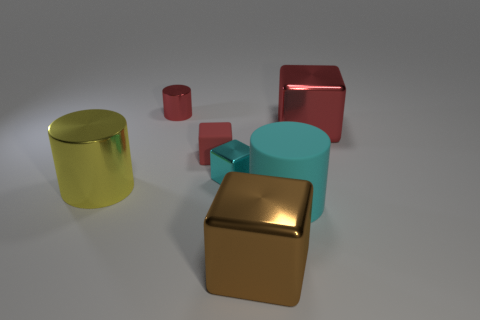Is the number of small green metallic cylinders less than the number of large cylinders?
Ensure brevity in your answer.  Yes. The small matte object that is the same shape as the cyan shiny thing is what color?
Give a very brief answer. Red. Are there any other things that have the same shape as the large rubber object?
Provide a short and direct response. Yes. Is the number of big blocks greater than the number of cyan cylinders?
Offer a terse response. Yes. How many other objects are there of the same material as the large cyan object?
Your answer should be very brief. 1. What is the shape of the cyan thing that is to the right of the big metal cube on the left side of the large block to the right of the cyan rubber object?
Provide a short and direct response. Cylinder. Is the number of yellow objects right of the red shiny block less than the number of red metal things left of the tiny matte object?
Provide a succinct answer. Yes. Are there any matte things of the same color as the tiny metal cube?
Keep it short and to the point. Yes. Is the yellow object made of the same material as the big cylinder on the right side of the red cylinder?
Keep it short and to the point. No. Are there any big shiny cylinders in front of the big cylinder left of the small cylinder?
Your response must be concise. No. 